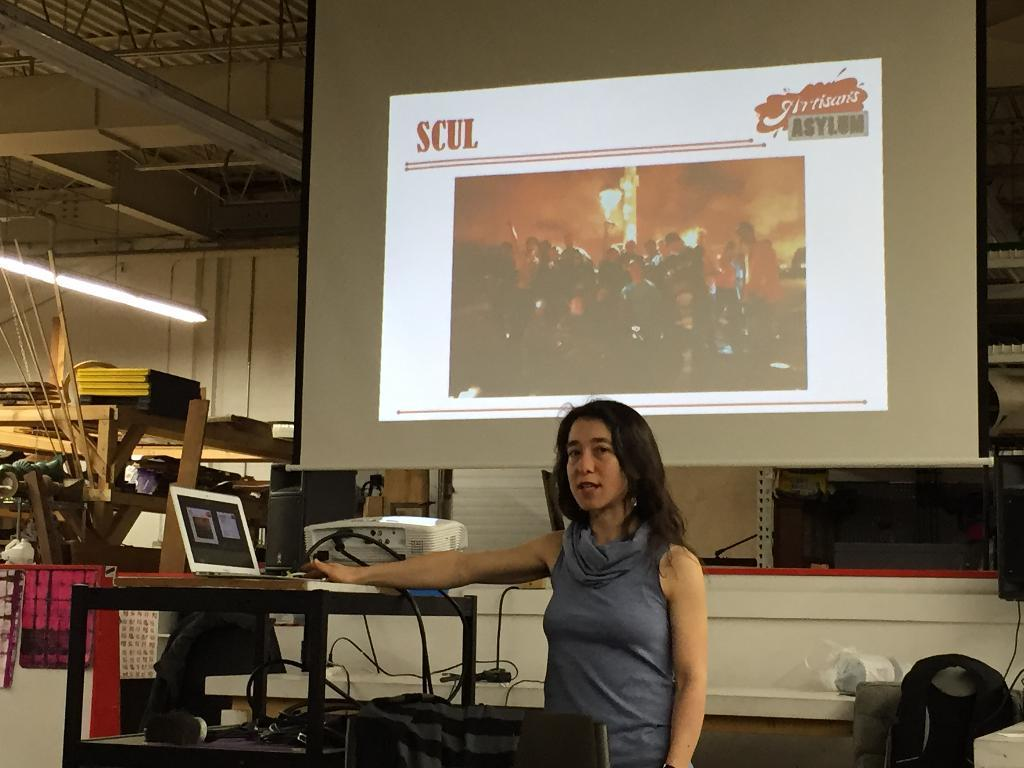<image>
Create a compact narrative representing the image presented. Woman giving a presentation with a screen saying "SCUL". 